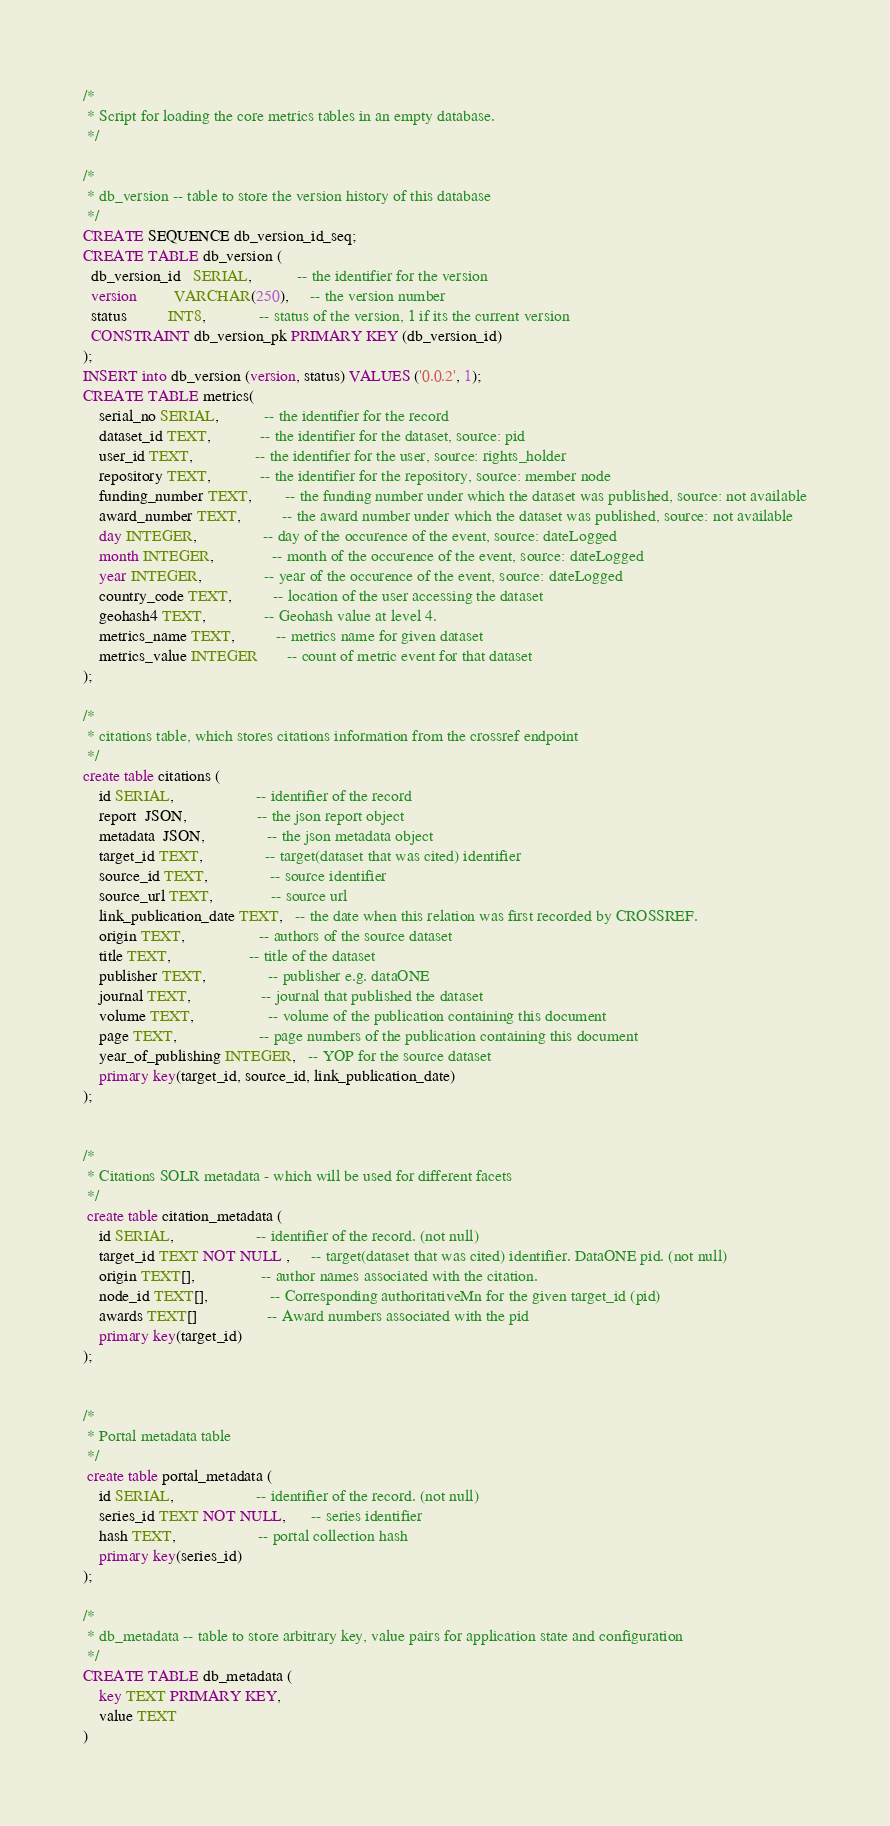Convert code to text. <code><loc_0><loc_0><loc_500><loc_500><_SQL_>/*
 * Script for loading the core metrics tables in an empty database.
 */

/*
 * db_version -- table to store the version history of this database
 */
CREATE SEQUENCE db_version_id_seq;
CREATE TABLE db_version (
  db_version_id   SERIAL,           -- the identifier for the version
  version         VARCHAR(250),     -- the version number
  status          INT8,             -- status of the version, 1 if its the current version
  CONSTRAINT db_version_pk PRIMARY KEY (db_version_id)
);
INSERT into db_version (version, status) VALUES ('0.0.2', 1);
CREATE TABLE metrics(
    serial_no SERIAL,           -- the identifier for the record
    dataset_id TEXT,            -- the identifier for the dataset, source: pid
    user_id TEXT,               -- the identifier for the user, source: rights_holder
    repository TEXT,            -- the identifier for the repository, source: member node
    funding_number TEXT,        -- the funding number under which the dataset was published, source: not available
    award_number TEXT,          -- the award number under which the dataset was published, source: not available
    day INTEGER,                -- day of the occurence of the event, source: dateLogged
    month INTEGER,              -- month of the occurence of the event, source: dateLogged
    year INTEGER,               -- year of the occurence of the event, source: dateLogged
    country_code TEXT,          -- location of the user accessing the dataset
    geohash4 TEXT,              -- Geohash value at level 4.
    metrics_name TEXT,          -- metrics name for given dataset
    metrics_value INTEGER       -- count of metric event for that dataset
);

/*
 * citations table, which stores citations information from the crossref endpoint
 */
create table citations (
    id SERIAL,                    -- identifier of the record
    report  JSON,                 -- the json report object
    metadata  JSON,               -- the json metadata object
    target_id TEXT,               -- target(dataset that was cited) identifier
    source_id TEXT,               -- source identifier
    source_url TEXT,              -- source url
    link_publication_date TEXT,   -- the date when this relation was first recorded by CROSSREF.
    origin TEXT,                  -- authors of the source dataset
    title TEXT,                   -- title of the dataset
    publisher TEXT,               -- publisher e.g. dataONE
    journal TEXT,                 -- journal that published the dataset
    volume TEXT,                  -- volume of the publication containing this document
    page TEXT,                    -- page numbers of the publication containing this document
    year_of_publishing INTEGER,   -- YOP for the source dataset
    primary key(target_id, source_id, link_publication_date)
);


/*
 * Citations SOLR metadata - which will be used for different facets
 */
 create table citation_metadata (
    id SERIAL,                    -- identifier of the record. (not null)
    target_id TEXT NOT NULL ,     -- target(dataset that was cited) identifier. DataONE pid. (not null)
    origin TEXT[],                -- author names associated with the citation.
    node_id TEXT[],               -- Corresponding authoritativeMn for the given target_id (pid)
    awards TEXT[]                 -- Award numbers associated with the pid
    primary key(target_id)
);


/*
 * Portal metadata table
 */
 create table portal_metadata (
    id SERIAL,                    -- identifier of the record. (not null)
    series_id TEXT NOT NULL,      -- series identifier
    hash TEXT,                    -- portal collection hash
    primary key(series_id)
);

/*
 * db_metadata -- table to store arbitrary key, value pairs for application state and configuration
 */
CREATE TABLE db_metadata (
    key TEXT PRIMARY KEY,
    value TEXT
)</code> 